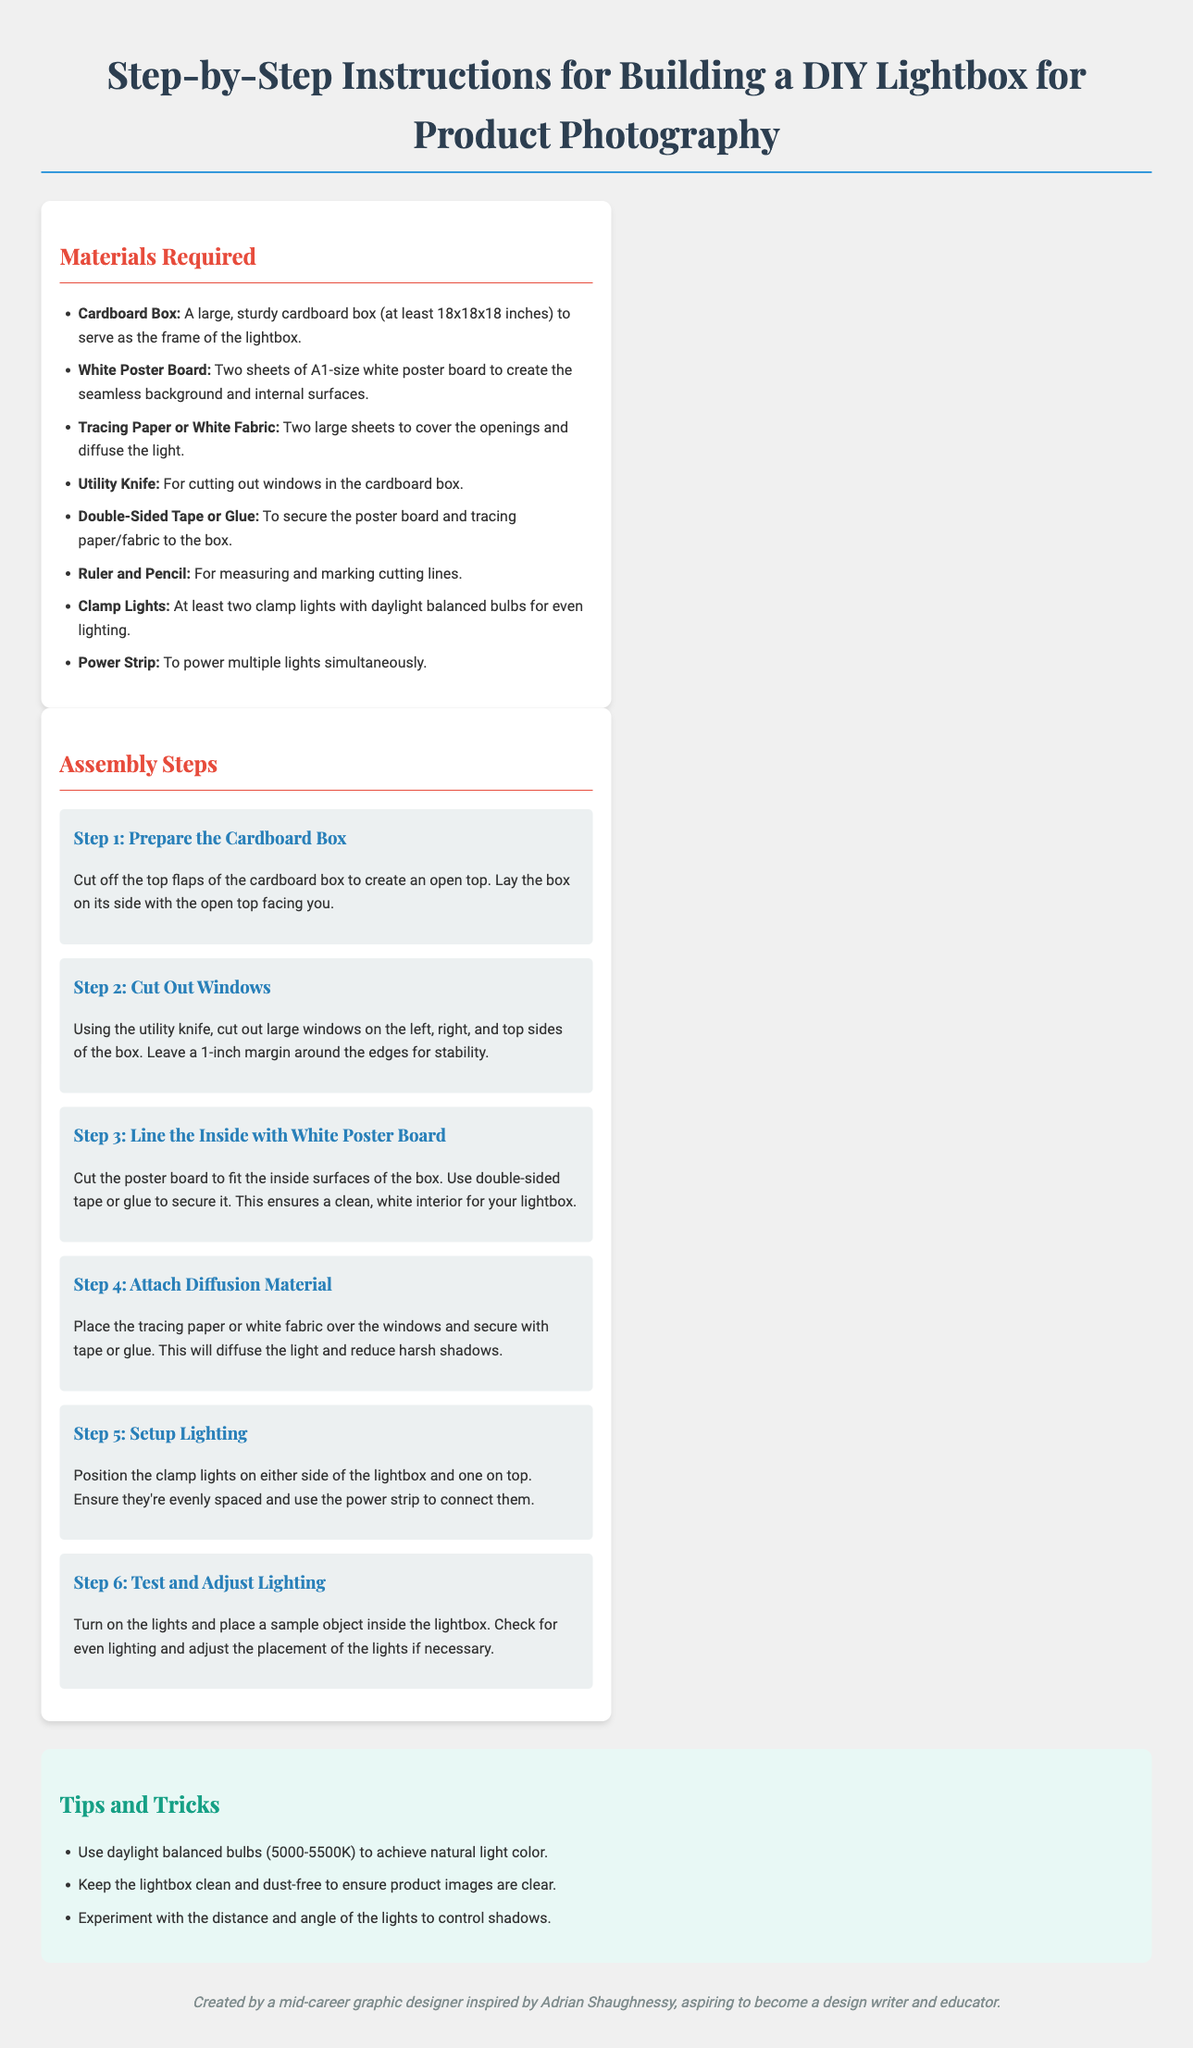What materials are required for the lightbox? The materials listed in the document include cardboard box, white poster board, tracing paper or white fabric, utility knife, double-sided tape or glue, ruler and pencil, clamp lights, and power strip.
Answer: Cardboard box, white poster board, tracing paper or white fabric, utility knife, double-sided tape or glue, ruler and pencil, clamp lights, power strip How many clamp lights are needed? The document specifies that at least two clamp lights are required for even lighting.
Answer: At least two What is the size of the cardboard box? The document mentions that the cardboard box should be at least 18x18x18 inches.
Answer: 18x18x18 inches Which step involves attaching the diffusion material? The fourth step specifically discusses attaching the tracing paper or white fabric to diffuse the light.
Answer: Step 4 What type of bulbs are recommended for lighting? The document states that daylight balanced bulbs (5000-5500K) should be used for natural light color.
Answer: Daylight balanced bulbs (5000-5500K) What is the first step in the assembly process? The first step is to prepare the cardboard box by cutting off the top flaps.
Answer: Prepare the Cardboard Box How should the lights be positioned in relation to the lightbox? The document recommends positioning the clamp lights on either side and one on top of the lightbox.
Answer: On either side and one on top What is the purpose of the white poster board? The white poster board is used to create the seamless background and internal surfaces of the lightbox.
Answer: Seamless background and internal surfaces Which tool is used for cutting the windows? The document specifies that the utility knife is the tool required for cutting out windows in the cardboard box.
Answer: Utility knife 